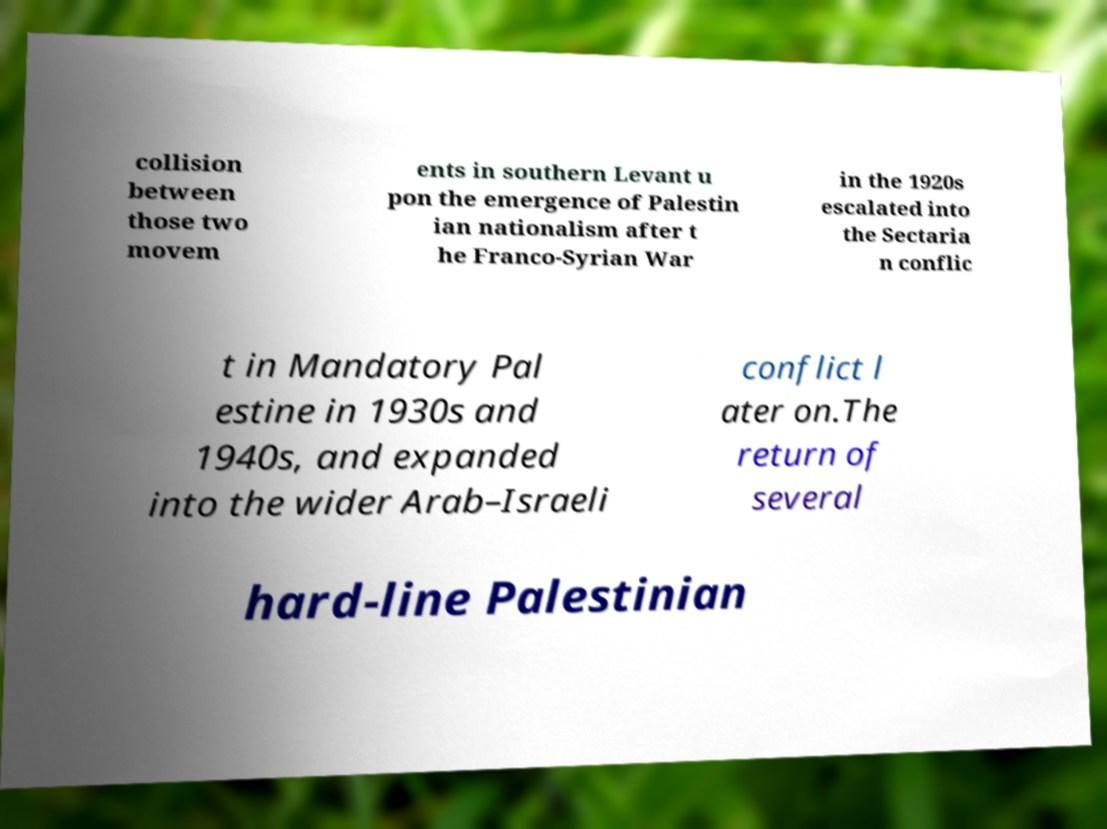There's text embedded in this image that I need extracted. Can you transcribe it verbatim? collision between those two movem ents in southern Levant u pon the emergence of Palestin ian nationalism after t he Franco-Syrian War in the 1920s escalated into the Sectaria n conflic t in Mandatory Pal estine in 1930s and 1940s, and expanded into the wider Arab–Israeli conflict l ater on.The return of several hard-line Palestinian 